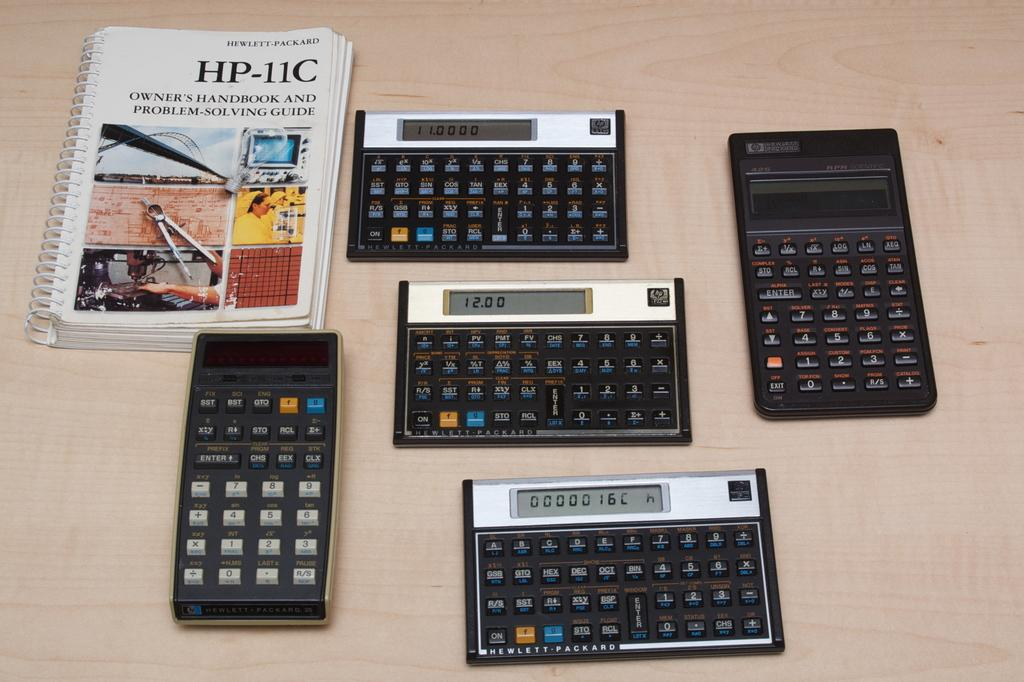Provide a one-sentence caption for the provided image. Five Hewlett-Packard calculators are arranged on a table next to an owner's manual and problem-solving guide. 